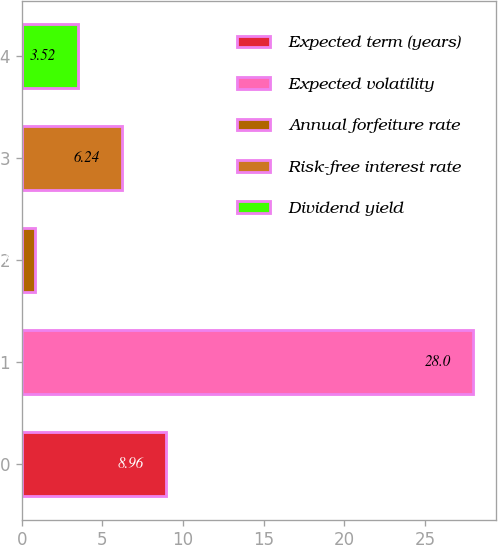Convert chart to OTSL. <chart><loc_0><loc_0><loc_500><loc_500><bar_chart><fcel>Expected term (years)<fcel>Expected volatility<fcel>Annual forfeiture rate<fcel>Risk-free interest rate<fcel>Dividend yield<nl><fcel>8.96<fcel>28<fcel>0.8<fcel>6.24<fcel>3.52<nl></chart> 